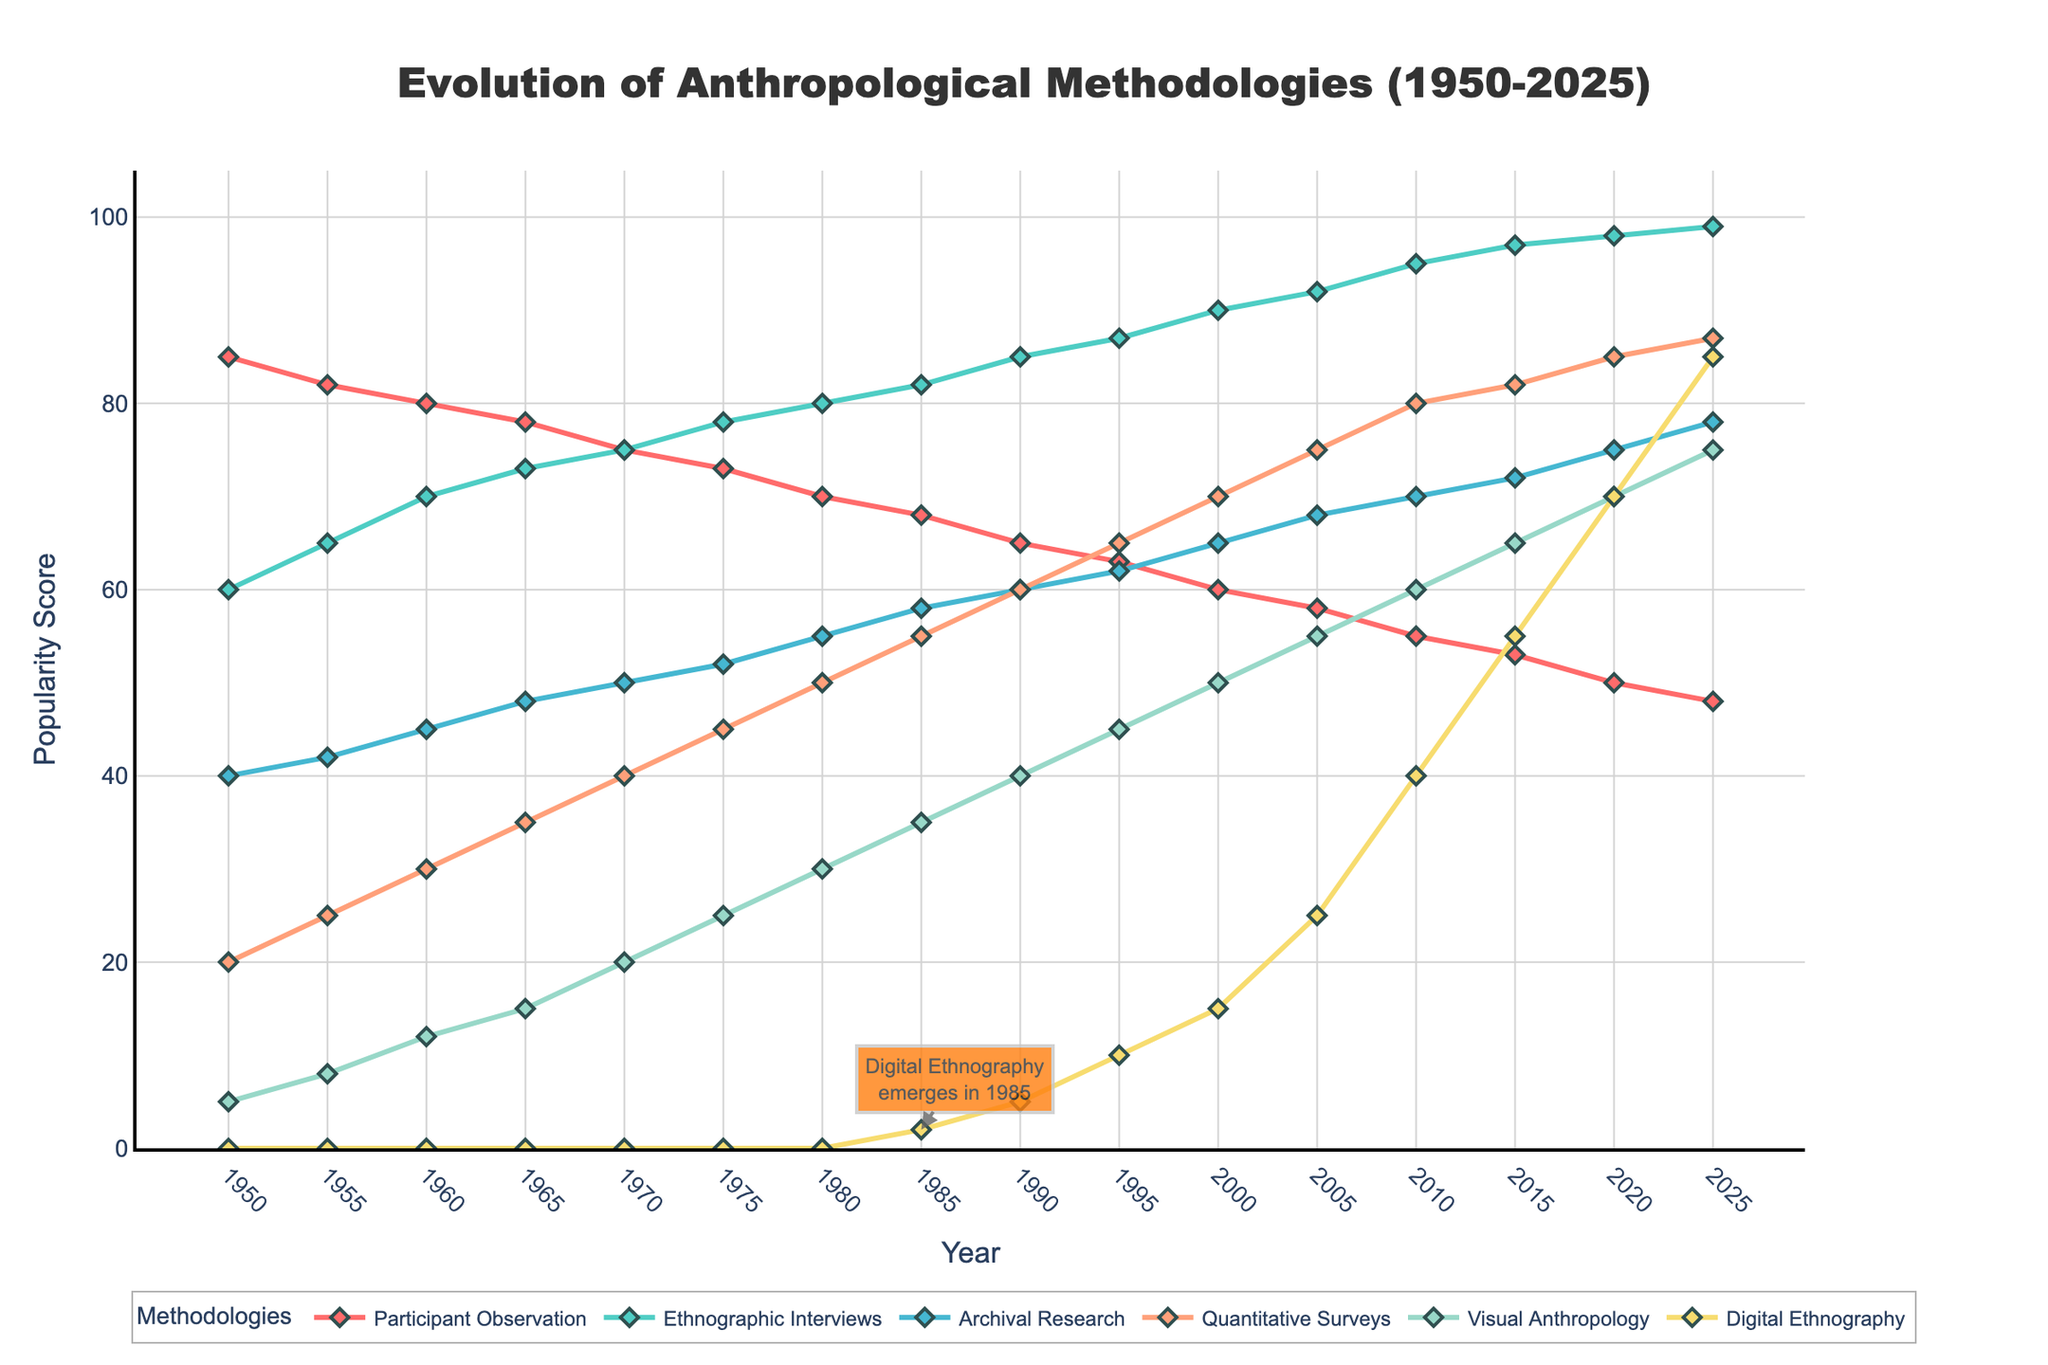Which methodology was the most popular in 1950? In 1950, Participant Observation had the highest popularity score among all methodologies with a value of 85.
Answer: Participant Observation What is the trend of Digital Ethnography according to the figure? Digital Ethnography starts at 0 in 1950, appears in 1985 with a score of 2, and increases steadily to 85 by 2025.
Answer: Steadily increasing Which two methodologies showed similar levels of popularity in 1970? In 1970, Ethnographic Interviews and Participant Observation had similar popularity scores, 75 and 75, respectively.
Answer: Ethnographic Interviews and Participant Observation Between 1990 and 2020, what is the increase in the popularity of Quantitative Surveys? The popularity of Quantitative Surveys increased from 60 in 1990 to 85 in 2020. The increase is 85 - 60 = 25.
Answer: 25 What color represents Visual Anthropology in the plot? Visual Anthropology is represented by the green line in the plot.
Answer: Green Which methodology shows the most significant increase in popularity from 1985 to 2025? Digital Ethnography increases from a score of 2 in 1985 to 85 in 2025, which is the largest increase among all methodologies, 83 points.
Answer: Digital Ethnography In what period did Archival Research overtake Participant Observation in popularity? Archival Research overtakes Participant Observation between 2010 and 2015.
Answer: Between 2010 and 2015 Looking at the figure, which visual attribute signifies the arrow marking the emergence of Digital Ethnography, and what year is it annotated? The figure has an arrow pointing to 1985, marking the start of Digital Ethnography with a score of 2.
Answer: Arrow; 1985 How does the popularity score of Participant Observation in 2000 compare to Ethnographic Interviews in 1960? Participant Observation has a score of 60 in 2000 while Ethnographic Interviews has a score of 70 in 1960, indicating that Ethnographic Interviews was more popular in 1960.
Answer: Ethnographic Interviews in 1960 Which methodologies display a convergence in popularity around 1965? In 1965, both Ethnographic Interviews at 73 and Participant Observation at 78 show close popularity scores.
Answer: Ethnographic Interviews and Participant Observation 